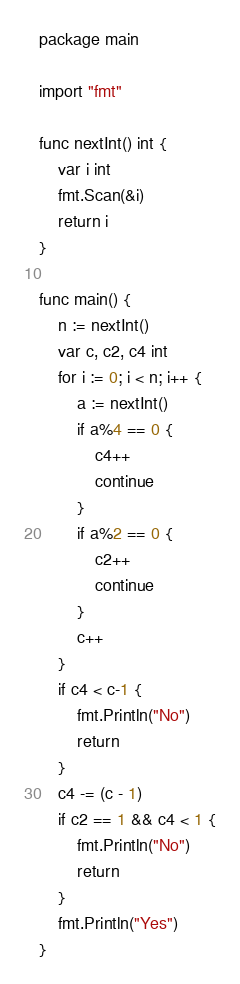<code> <loc_0><loc_0><loc_500><loc_500><_Go_>package main

import "fmt"

func nextInt() int {
	var i int
	fmt.Scan(&i)
	return i
}

func main() {
	n := nextInt()
	var c, c2, c4 int
	for i := 0; i < n; i++ {
		a := nextInt()
		if a%4 == 0 {
			c4++
			continue
		}
		if a%2 == 0 {
			c2++
			continue
		}
		c++
	}
	if c4 < c-1 {
		fmt.Println("No")
		return
	}
	c4 -= (c - 1)
	if c2 == 1 && c4 < 1 {
		fmt.Println("No")
		return
	}
	fmt.Println("Yes")
}</code> 